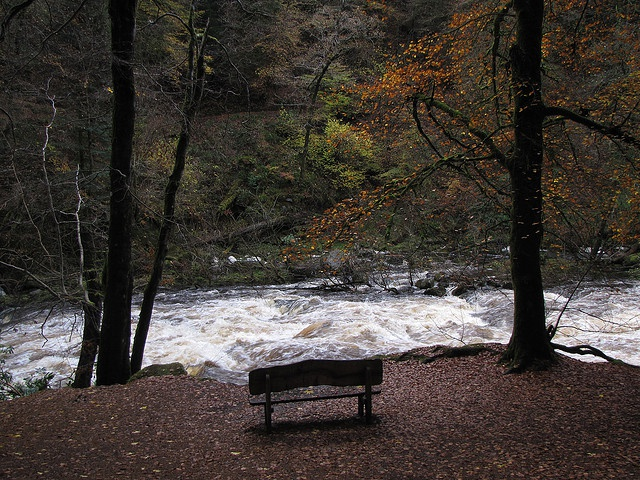Describe the objects in this image and their specific colors. I can see a bench in black, gray, and darkgray tones in this image. 